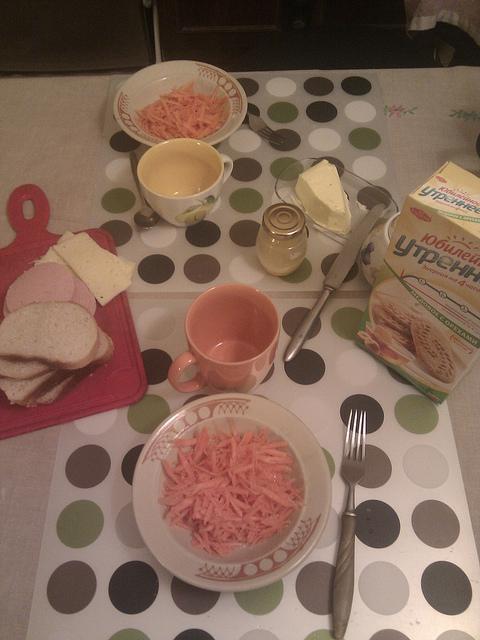How many bowels are on the table?
Give a very brief answer. 0. How many bowls are in the picture?
Give a very brief answer. 2. How many cups are visible?
Give a very brief answer. 2. 